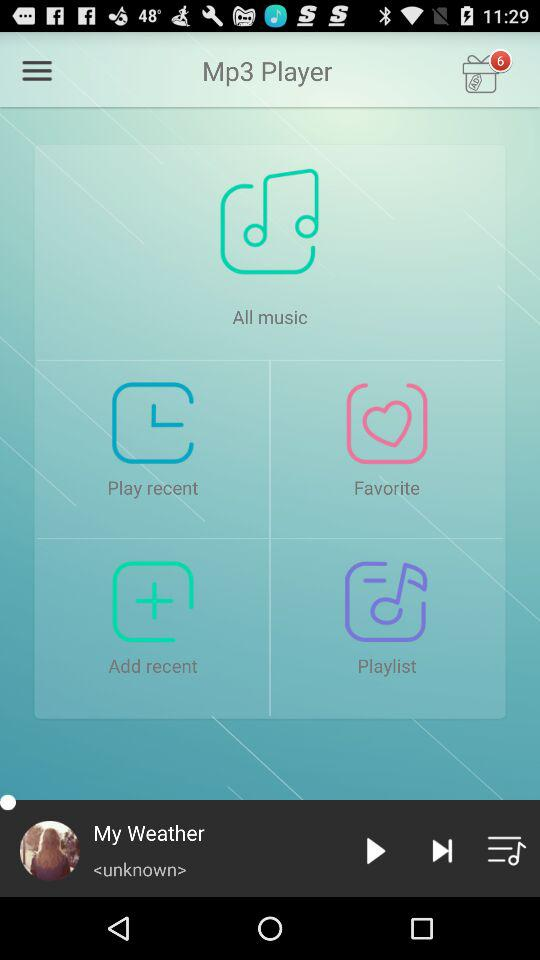How many notifications are pending? There are 6 notifications pending. 